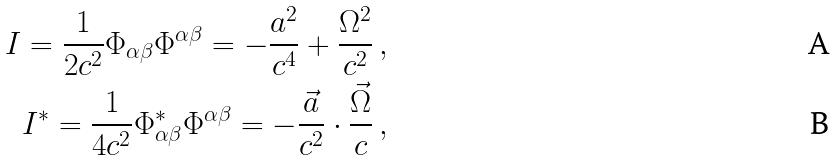<formula> <loc_0><loc_0><loc_500><loc_500>I = \frac { 1 } { 2 c ^ { 2 } } \Phi _ { \alpha \beta } \Phi ^ { \alpha \beta } = - \frac { a ^ { 2 } } { c ^ { 4 } } + \frac { \Omega ^ { 2 } } { c ^ { 2 } } \, , \\ I ^ { * } = \frac { 1 } { 4 c ^ { 2 } } \Phi _ { \alpha \beta } ^ { * } \Phi ^ { \alpha \beta } = - \frac { \vec { a } } { c ^ { 2 } } \cdot \frac { \vec { \Omega } } { c } \, ,</formula> 